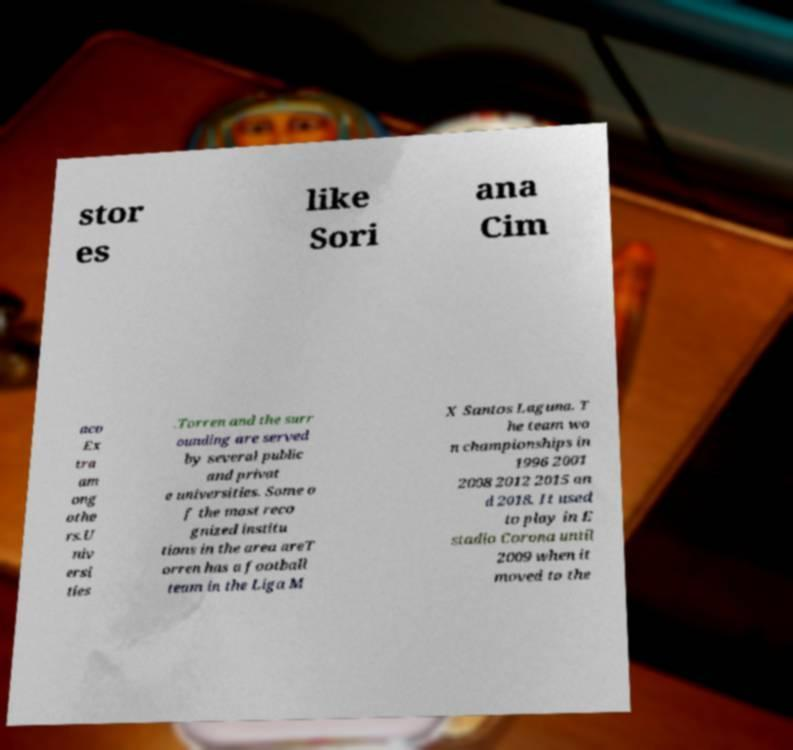Can you accurately transcribe the text from the provided image for me? stor es like Sori ana Cim aco Ex tra am ong othe rs.U niv ersi ties .Torren and the surr ounding are served by several public and privat e universities. Some o f the most reco gnized institu tions in the area areT orren has a football team in the Liga M X Santos Laguna. T he team wo n championships in 1996 2001 2008 2012 2015 an d 2018. It used to play in E stadio Corona until 2009 when it moved to the 